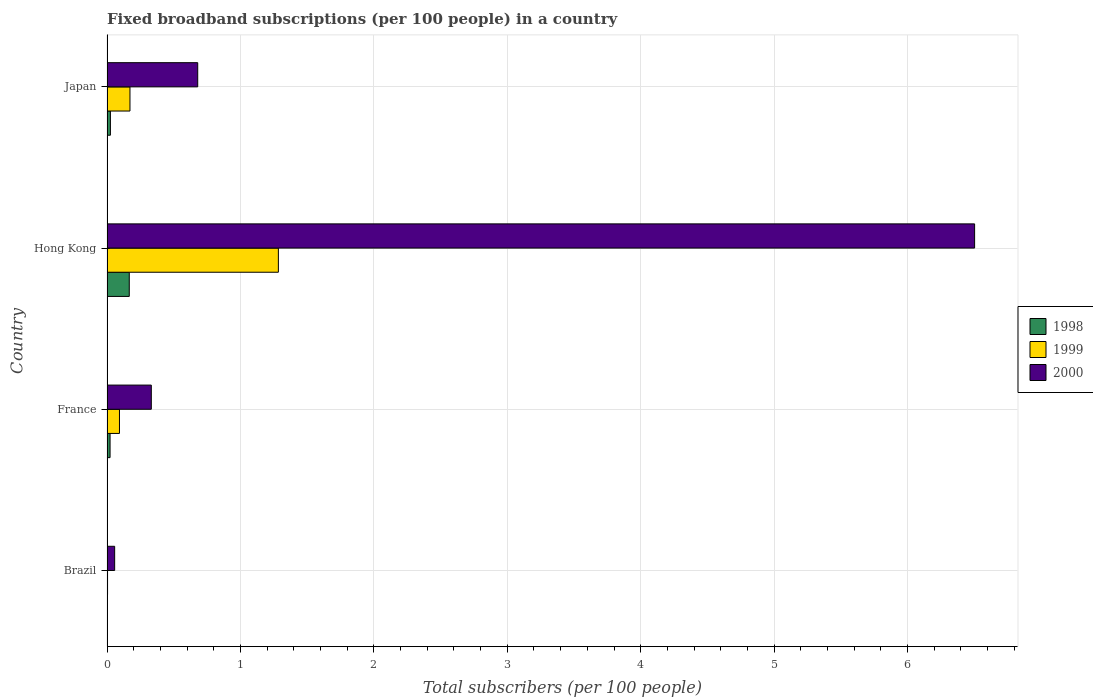How many different coloured bars are there?
Your answer should be compact. 3. How many groups of bars are there?
Offer a very short reply. 4. Are the number of bars per tick equal to the number of legend labels?
Your response must be concise. Yes. Are the number of bars on each tick of the Y-axis equal?
Ensure brevity in your answer.  Yes. How many bars are there on the 4th tick from the top?
Your answer should be compact. 3. How many bars are there on the 1st tick from the bottom?
Provide a short and direct response. 3. What is the label of the 2nd group of bars from the top?
Offer a very short reply. Hong Kong. What is the number of broadband subscriptions in 2000 in Brazil?
Your response must be concise. 0.06. Across all countries, what is the maximum number of broadband subscriptions in 1999?
Ensure brevity in your answer.  1.28. Across all countries, what is the minimum number of broadband subscriptions in 1998?
Ensure brevity in your answer.  0. In which country was the number of broadband subscriptions in 2000 maximum?
Your answer should be compact. Hong Kong. In which country was the number of broadband subscriptions in 2000 minimum?
Keep it short and to the point. Brazil. What is the total number of broadband subscriptions in 1998 in the graph?
Make the answer very short. 0.22. What is the difference between the number of broadband subscriptions in 1999 in Brazil and that in France?
Give a very brief answer. -0.09. What is the difference between the number of broadband subscriptions in 1999 in Japan and the number of broadband subscriptions in 2000 in Hong Kong?
Give a very brief answer. -6.33. What is the average number of broadband subscriptions in 1998 per country?
Your answer should be compact. 0.05. What is the difference between the number of broadband subscriptions in 1999 and number of broadband subscriptions in 2000 in Brazil?
Provide a succinct answer. -0.05. In how many countries, is the number of broadband subscriptions in 2000 greater than 1.4 ?
Offer a terse response. 1. What is the ratio of the number of broadband subscriptions in 1998 in France to that in Japan?
Ensure brevity in your answer.  0.9. Is the number of broadband subscriptions in 2000 in Brazil less than that in France?
Your response must be concise. Yes. What is the difference between the highest and the second highest number of broadband subscriptions in 2000?
Provide a short and direct response. 5.82. What is the difference between the highest and the lowest number of broadband subscriptions in 1999?
Offer a very short reply. 1.28. What does the 1st bar from the top in Japan represents?
Ensure brevity in your answer.  2000. What does the 3rd bar from the bottom in Japan represents?
Keep it short and to the point. 2000. Is it the case that in every country, the sum of the number of broadband subscriptions in 1998 and number of broadband subscriptions in 2000 is greater than the number of broadband subscriptions in 1999?
Provide a succinct answer. Yes. What is the difference between two consecutive major ticks on the X-axis?
Make the answer very short. 1. Are the values on the major ticks of X-axis written in scientific E-notation?
Ensure brevity in your answer.  No. Does the graph contain any zero values?
Ensure brevity in your answer.  No. Where does the legend appear in the graph?
Make the answer very short. Center right. What is the title of the graph?
Provide a short and direct response. Fixed broadband subscriptions (per 100 people) in a country. Does "1990" appear as one of the legend labels in the graph?
Provide a short and direct response. No. What is the label or title of the X-axis?
Offer a terse response. Total subscribers (per 100 people). What is the Total subscribers (per 100 people) in 1998 in Brazil?
Make the answer very short. 0. What is the Total subscribers (per 100 people) in 1999 in Brazil?
Your response must be concise. 0. What is the Total subscribers (per 100 people) of 2000 in Brazil?
Your answer should be compact. 0.06. What is the Total subscribers (per 100 people) in 1998 in France?
Provide a succinct answer. 0.02. What is the Total subscribers (per 100 people) of 1999 in France?
Ensure brevity in your answer.  0.09. What is the Total subscribers (per 100 people) of 2000 in France?
Offer a terse response. 0.33. What is the Total subscribers (per 100 people) in 1998 in Hong Kong?
Offer a terse response. 0.17. What is the Total subscribers (per 100 people) of 1999 in Hong Kong?
Your response must be concise. 1.28. What is the Total subscribers (per 100 people) of 2000 in Hong Kong?
Offer a very short reply. 6.5. What is the Total subscribers (per 100 people) in 1998 in Japan?
Your response must be concise. 0.03. What is the Total subscribers (per 100 people) in 1999 in Japan?
Offer a terse response. 0.17. What is the Total subscribers (per 100 people) in 2000 in Japan?
Ensure brevity in your answer.  0.68. Across all countries, what is the maximum Total subscribers (per 100 people) in 1998?
Your response must be concise. 0.17. Across all countries, what is the maximum Total subscribers (per 100 people) of 1999?
Give a very brief answer. 1.28. Across all countries, what is the maximum Total subscribers (per 100 people) in 2000?
Provide a short and direct response. 6.5. Across all countries, what is the minimum Total subscribers (per 100 people) in 1998?
Ensure brevity in your answer.  0. Across all countries, what is the minimum Total subscribers (per 100 people) in 1999?
Your response must be concise. 0. Across all countries, what is the minimum Total subscribers (per 100 people) in 2000?
Your answer should be very brief. 0.06. What is the total Total subscribers (per 100 people) of 1998 in the graph?
Your answer should be very brief. 0.22. What is the total Total subscribers (per 100 people) of 1999 in the graph?
Keep it short and to the point. 1.55. What is the total Total subscribers (per 100 people) of 2000 in the graph?
Give a very brief answer. 7.57. What is the difference between the Total subscribers (per 100 people) of 1998 in Brazil and that in France?
Provide a short and direct response. -0.02. What is the difference between the Total subscribers (per 100 people) of 1999 in Brazil and that in France?
Your answer should be compact. -0.09. What is the difference between the Total subscribers (per 100 people) in 2000 in Brazil and that in France?
Your answer should be compact. -0.27. What is the difference between the Total subscribers (per 100 people) in 1998 in Brazil and that in Hong Kong?
Your answer should be very brief. -0.17. What is the difference between the Total subscribers (per 100 people) in 1999 in Brazil and that in Hong Kong?
Provide a succinct answer. -1.28. What is the difference between the Total subscribers (per 100 people) in 2000 in Brazil and that in Hong Kong?
Give a very brief answer. -6.45. What is the difference between the Total subscribers (per 100 people) of 1998 in Brazil and that in Japan?
Your answer should be very brief. -0.03. What is the difference between the Total subscribers (per 100 people) in 1999 in Brazil and that in Japan?
Give a very brief answer. -0.17. What is the difference between the Total subscribers (per 100 people) in 2000 in Brazil and that in Japan?
Make the answer very short. -0.62. What is the difference between the Total subscribers (per 100 people) of 1998 in France and that in Hong Kong?
Your answer should be compact. -0.14. What is the difference between the Total subscribers (per 100 people) in 1999 in France and that in Hong Kong?
Give a very brief answer. -1.19. What is the difference between the Total subscribers (per 100 people) of 2000 in France and that in Hong Kong?
Provide a short and direct response. -6.17. What is the difference between the Total subscribers (per 100 people) of 1998 in France and that in Japan?
Your answer should be very brief. -0. What is the difference between the Total subscribers (per 100 people) in 1999 in France and that in Japan?
Offer a very short reply. -0.08. What is the difference between the Total subscribers (per 100 people) in 2000 in France and that in Japan?
Give a very brief answer. -0.35. What is the difference between the Total subscribers (per 100 people) of 1998 in Hong Kong and that in Japan?
Make the answer very short. 0.14. What is the difference between the Total subscribers (per 100 people) in 1999 in Hong Kong and that in Japan?
Provide a succinct answer. 1.11. What is the difference between the Total subscribers (per 100 people) in 2000 in Hong Kong and that in Japan?
Give a very brief answer. 5.82. What is the difference between the Total subscribers (per 100 people) in 1998 in Brazil and the Total subscribers (per 100 people) in 1999 in France?
Keep it short and to the point. -0.09. What is the difference between the Total subscribers (per 100 people) in 1998 in Brazil and the Total subscribers (per 100 people) in 2000 in France?
Provide a succinct answer. -0.33. What is the difference between the Total subscribers (per 100 people) in 1999 in Brazil and the Total subscribers (per 100 people) in 2000 in France?
Your answer should be very brief. -0.33. What is the difference between the Total subscribers (per 100 people) of 1998 in Brazil and the Total subscribers (per 100 people) of 1999 in Hong Kong?
Your answer should be very brief. -1.28. What is the difference between the Total subscribers (per 100 people) in 1998 in Brazil and the Total subscribers (per 100 people) in 2000 in Hong Kong?
Ensure brevity in your answer.  -6.5. What is the difference between the Total subscribers (per 100 people) of 1999 in Brazil and the Total subscribers (per 100 people) of 2000 in Hong Kong?
Your response must be concise. -6.5. What is the difference between the Total subscribers (per 100 people) of 1998 in Brazil and the Total subscribers (per 100 people) of 1999 in Japan?
Make the answer very short. -0.17. What is the difference between the Total subscribers (per 100 people) in 1998 in Brazil and the Total subscribers (per 100 people) in 2000 in Japan?
Offer a terse response. -0.68. What is the difference between the Total subscribers (per 100 people) of 1999 in Brazil and the Total subscribers (per 100 people) of 2000 in Japan?
Offer a very short reply. -0.68. What is the difference between the Total subscribers (per 100 people) of 1998 in France and the Total subscribers (per 100 people) of 1999 in Hong Kong?
Your answer should be very brief. -1.26. What is the difference between the Total subscribers (per 100 people) of 1998 in France and the Total subscribers (per 100 people) of 2000 in Hong Kong?
Offer a terse response. -6.48. What is the difference between the Total subscribers (per 100 people) of 1999 in France and the Total subscribers (per 100 people) of 2000 in Hong Kong?
Provide a short and direct response. -6.41. What is the difference between the Total subscribers (per 100 people) of 1998 in France and the Total subscribers (per 100 people) of 1999 in Japan?
Offer a very short reply. -0.15. What is the difference between the Total subscribers (per 100 people) of 1998 in France and the Total subscribers (per 100 people) of 2000 in Japan?
Your response must be concise. -0.66. What is the difference between the Total subscribers (per 100 people) of 1999 in France and the Total subscribers (per 100 people) of 2000 in Japan?
Provide a succinct answer. -0.59. What is the difference between the Total subscribers (per 100 people) in 1998 in Hong Kong and the Total subscribers (per 100 people) in 1999 in Japan?
Provide a short and direct response. -0.01. What is the difference between the Total subscribers (per 100 people) of 1998 in Hong Kong and the Total subscribers (per 100 people) of 2000 in Japan?
Ensure brevity in your answer.  -0.51. What is the difference between the Total subscribers (per 100 people) of 1999 in Hong Kong and the Total subscribers (per 100 people) of 2000 in Japan?
Your answer should be very brief. 0.6. What is the average Total subscribers (per 100 people) of 1998 per country?
Make the answer very short. 0.05. What is the average Total subscribers (per 100 people) of 1999 per country?
Offer a very short reply. 0.39. What is the average Total subscribers (per 100 people) in 2000 per country?
Ensure brevity in your answer.  1.89. What is the difference between the Total subscribers (per 100 people) in 1998 and Total subscribers (per 100 people) in 1999 in Brazil?
Offer a very short reply. -0. What is the difference between the Total subscribers (per 100 people) of 1998 and Total subscribers (per 100 people) of 2000 in Brazil?
Ensure brevity in your answer.  -0.06. What is the difference between the Total subscribers (per 100 people) in 1999 and Total subscribers (per 100 people) in 2000 in Brazil?
Keep it short and to the point. -0.05. What is the difference between the Total subscribers (per 100 people) in 1998 and Total subscribers (per 100 people) in 1999 in France?
Keep it short and to the point. -0.07. What is the difference between the Total subscribers (per 100 people) of 1998 and Total subscribers (per 100 people) of 2000 in France?
Offer a terse response. -0.31. What is the difference between the Total subscribers (per 100 people) of 1999 and Total subscribers (per 100 people) of 2000 in France?
Offer a very short reply. -0.24. What is the difference between the Total subscribers (per 100 people) of 1998 and Total subscribers (per 100 people) of 1999 in Hong Kong?
Ensure brevity in your answer.  -1.12. What is the difference between the Total subscribers (per 100 people) in 1998 and Total subscribers (per 100 people) in 2000 in Hong Kong?
Offer a very short reply. -6.34. What is the difference between the Total subscribers (per 100 people) in 1999 and Total subscribers (per 100 people) in 2000 in Hong Kong?
Ensure brevity in your answer.  -5.22. What is the difference between the Total subscribers (per 100 people) in 1998 and Total subscribers (per 100 people) in 1999 in Japan?
Your answer should be very brief. -0.15. What is the difference between the Total subscribers (per 100 people) in 1998 and Total subscribers (per 100 people) in 2000 in Japan?
Ensure brevity in your answer.  -0.65. What is the difference between the Total subscribers (per 100 people) of 1999 and Total subscribers (per 100 people) of 2000 in Japan?
Provide a succinct answer. -0.51. What is the ratio of the Total subscribers (per 100 people) of 1998 in Brazil to that in France?
Keep it short and to the point. 0.03. What is the ratio of the Total subscribers (per 100 people) of 1999 in Brazil to that in France?
Your answer should be very brief. 0.04. What is the ratio of the Total subscribers (per 100 people) in 2000 in Brazil to that in France?
Your answer should be compact. 0.17. What is the ratio of the Total subscribers (per 100 people) of 1998 in Brazil to that in Hong Kong?
Your answer should be compact. 0. What is the ratio of the Total subscribers (per 100 people) in 1999 in Brazil to that in Hong Kong?
Provide a short and direct response. 0. What is the ratio of the Total subscribers (per 100 people) of 2000 in Brazil to that in Hong Kong?
Your response must be concise. 0.01. What is the ratio of the Total subscribers (per 100 people) in 1998 in Brazil to that in Japan?
Your answer should be very brief. 0.02. What is the ratio of the Total subscribers (per 100 people) of 1999 in Brazil to that in Japan?
Your answer should be very brief. 0.02. What is the ratio of the Total subscribers (per 100 people) of 2000 in Brazil to that in Japan?
Your answer should be compact. 0.08. What is the ratio of the Total subscribers (per 100 people) of 1998 in France to that in Hong Kong?
Ensure brevity in your answer.  0.14. What is the ratio of the Total subscribers (per 100 people) in 1999 in France to that in Hong Kong?
Your answer should be compact. 0.07. What is the ratio of the Total subscribers (per 100 people) in 2000 in France to that in Hong Kong?
Make the answer very short. 0.05. What is the ratio of the Total subscribers (per 100 people) of 1998 in France to that in Japan?
Make the answer very short. 0.9. What is the ratio of the Total subscribers (per 100 people) in 1999 in France to that in Japan?
Offer a terse response. 0.54. What is the ratio of the Total subscribers (per 100 people) of 2000 in France to that in Japan?
Your answer should be compact. 0.49. What is the ratio of the Total subscribers (per 100 people) of 1998 in Hong Kong to that in Japan?
Make the answer very short. 6.53. What is the ratio of the Total subscribers (per 100 people) of 1999 in Hong Kong to that in Japan?
Offer a very short reply. 7.46. What is the ratio of the Total subscribers (per 100 people) in 2000 in Hong Kong to that in Japan?
Your response must be concise. 9.56. What is the difference between the highest and the second highest Total subscribers (per 100 people) of 1998?
Offer a terse response. 0.14. What is the difference between the highest and the second highest Total subscribers (per 100 people) of 1999?
Give a very brief answer. 1.11. What is the difference between the highest and the second highest Total subscribers (per 100 people) in 2000?
Offer a very short reply. 5.82. What is the difference between the highest and the lowest Total subscribers (per 100 people) of 1998?
Make the answer very short. 0.17. What is the difference between the highest and the lowest Total subscribers (per 100 people) in 1999?
Keep it short and to the point. 1.28. What is the difference between the highest and the lowest Total subscribers (per 100 people) in 2000?
Your response must be concise. 6.45. 